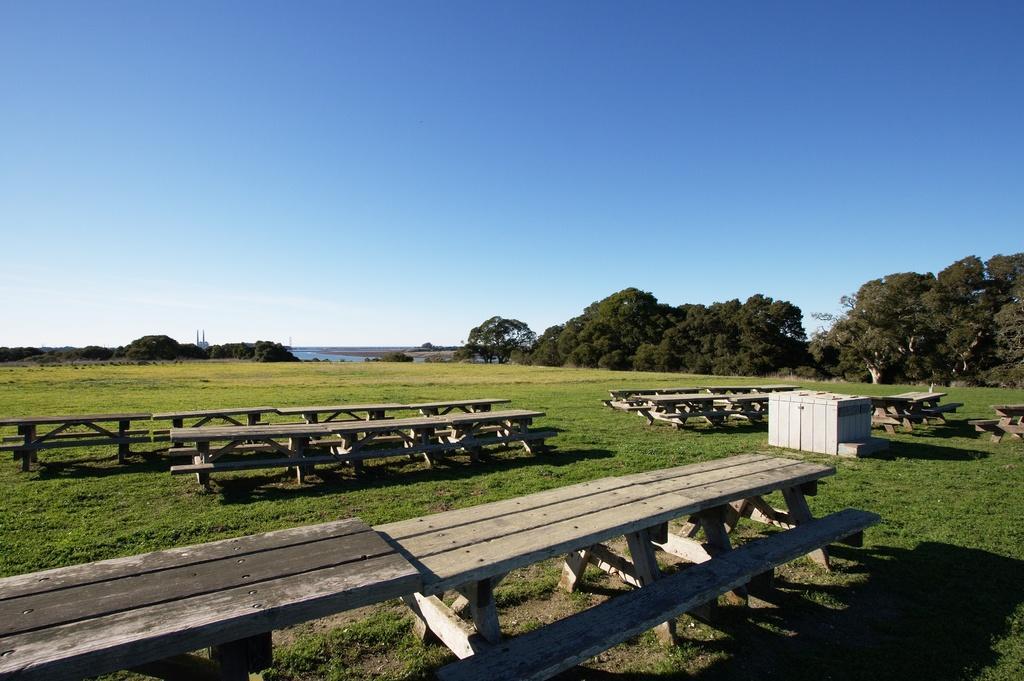Describe this image in one or two sentences. This picture is clicked outside. In the foreground we can see the benches and some other objects and we can see the green grass, plants, trees. In the background we can see the sky and some other objects. 